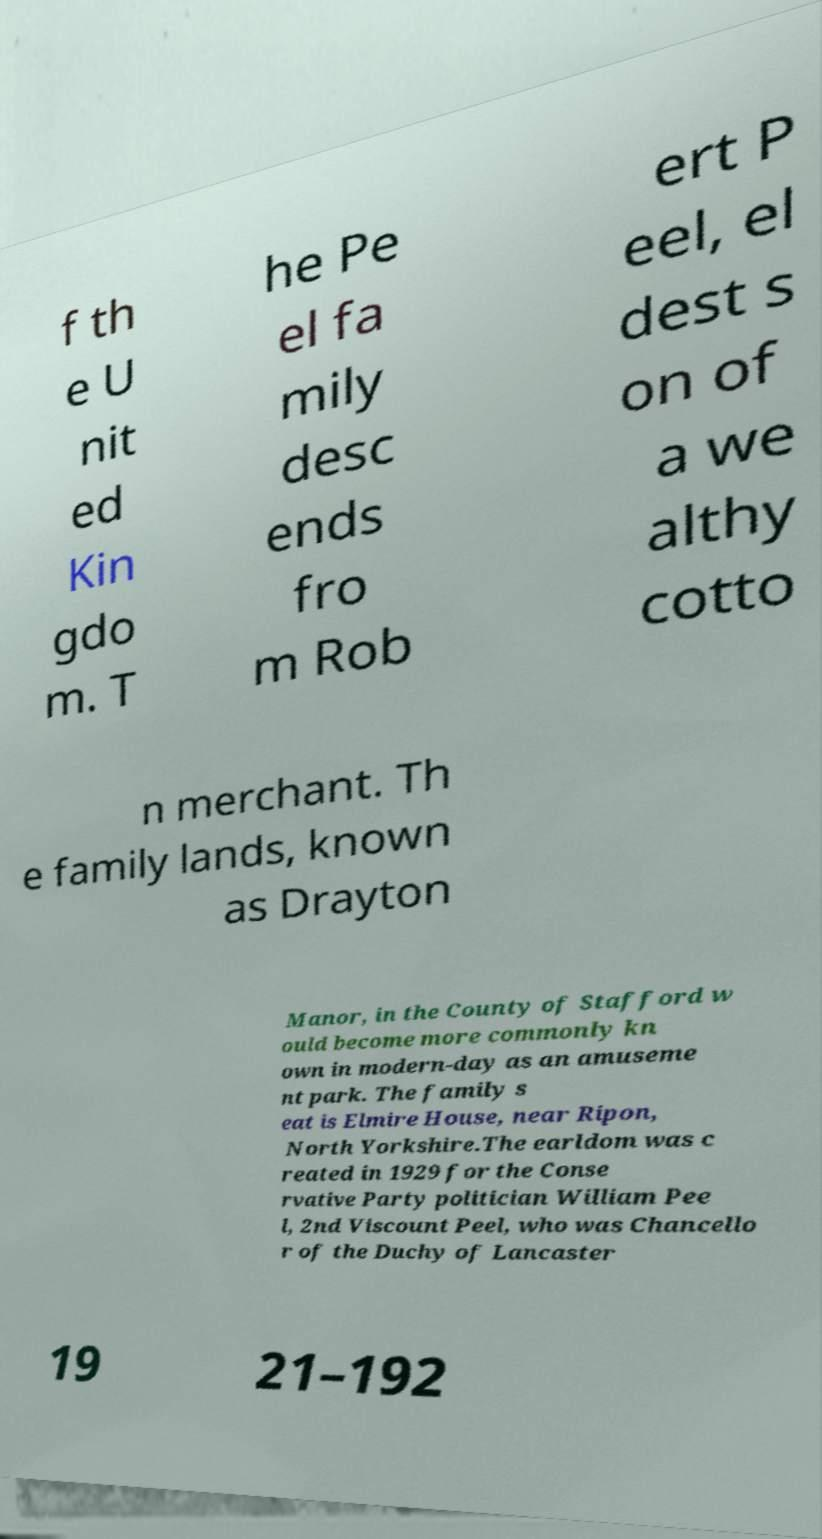Can you accurately transcribe the text from the provided image for me? f th e U nit ed Kin gdo m. T he Pe el fa mily desc ends fro m Rob ert P eel, el dest s on of a we althy cotto n merchant. Th e family lands, known as Drayton Manor, in the County of Stafford w ould become more commonly kn own in modern-day as an amuseme nt park. The family s eat is Elmire House, near Ripon, North Yorkshire.The earldom was c reated in 1929 for the Conse rvative Party politician William Pee l, 2nd Viscount Peel, who was Chancello r of the Duchy of Lancaster 19 21–192 